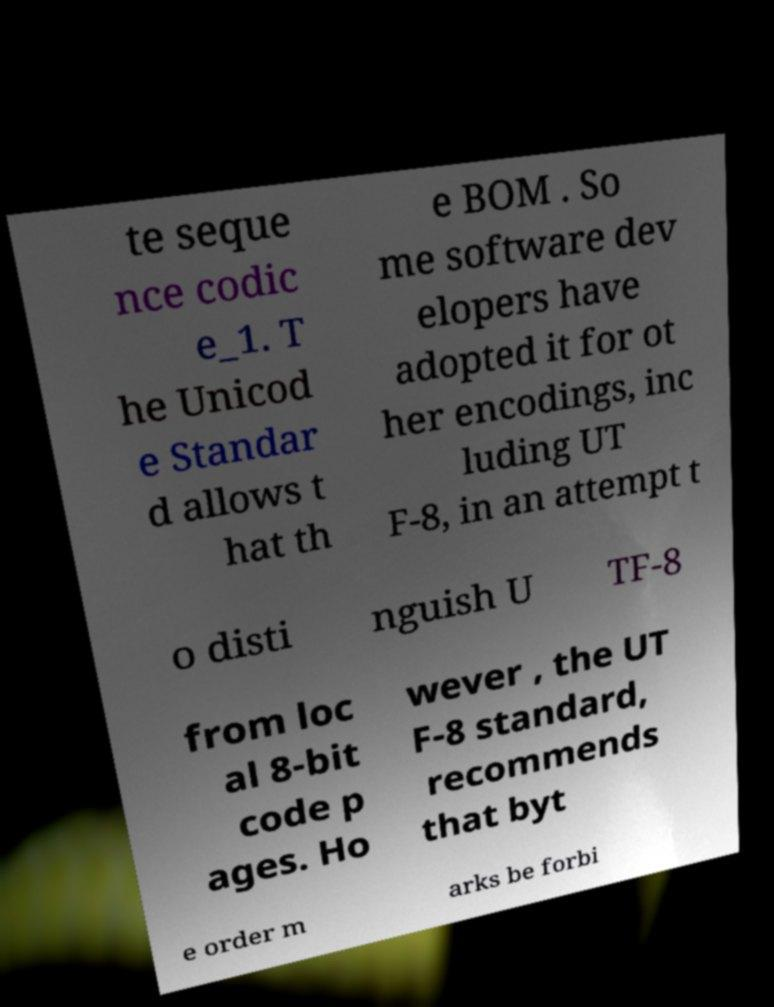For documentation purposes, I need the text within this image transcribed. Could you provide that? te seque nce codic e_1. T he Unicod e Standar d allows t hat th e BOM . So me software dev elopers have adopted it for ot her encodings, inc luding UT F-8, in an attempt t o disti nguish U TF-8 from loc al 8-bit code p ages. Ho wever , the UT F-8 standard, recommends that byt e order m arks be forbi 